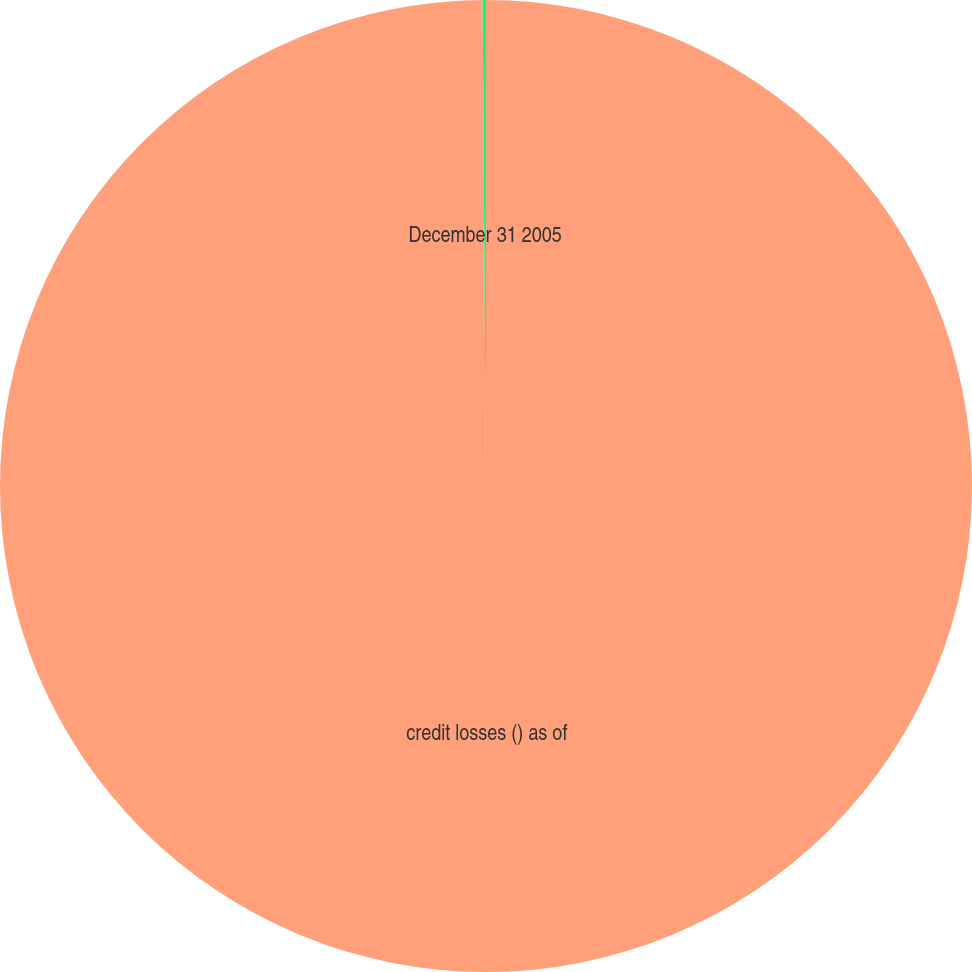Convert chart to OTSL. <chart><loc_0><loc_0><loc_500><loc_500><pie_chart><fcel>credit losses () as of<fcel>December 31 2005<nl><fcel>99.89%<fcel>0.11%<nl></chart> 